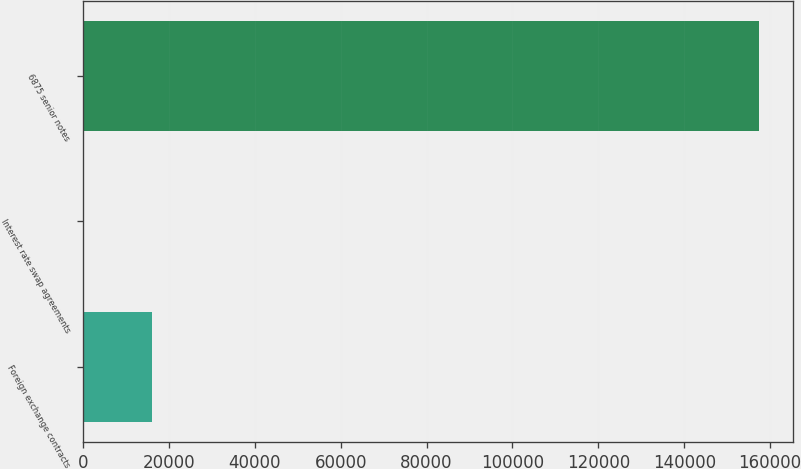<chart> <loc_0><loc_0><loc_500><loc_500><bar_chart><fcel>Foreign exchange contracts<fcel>Interest rate swap agreements<fcel>6875 senior notes<nl><fcel>15922.8<fcel>192<fcel>157500<nl></chart> 